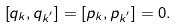<formula> <loc_0><loc_0><loc_500><loc_500>\left [ q _ { k } , q _ { k ^ { ^ { \prime } } } \right ] = \left [ p _ { k } , p _ { k ^ { ^ { \prime } } } \right ] = 0 .</formula> 